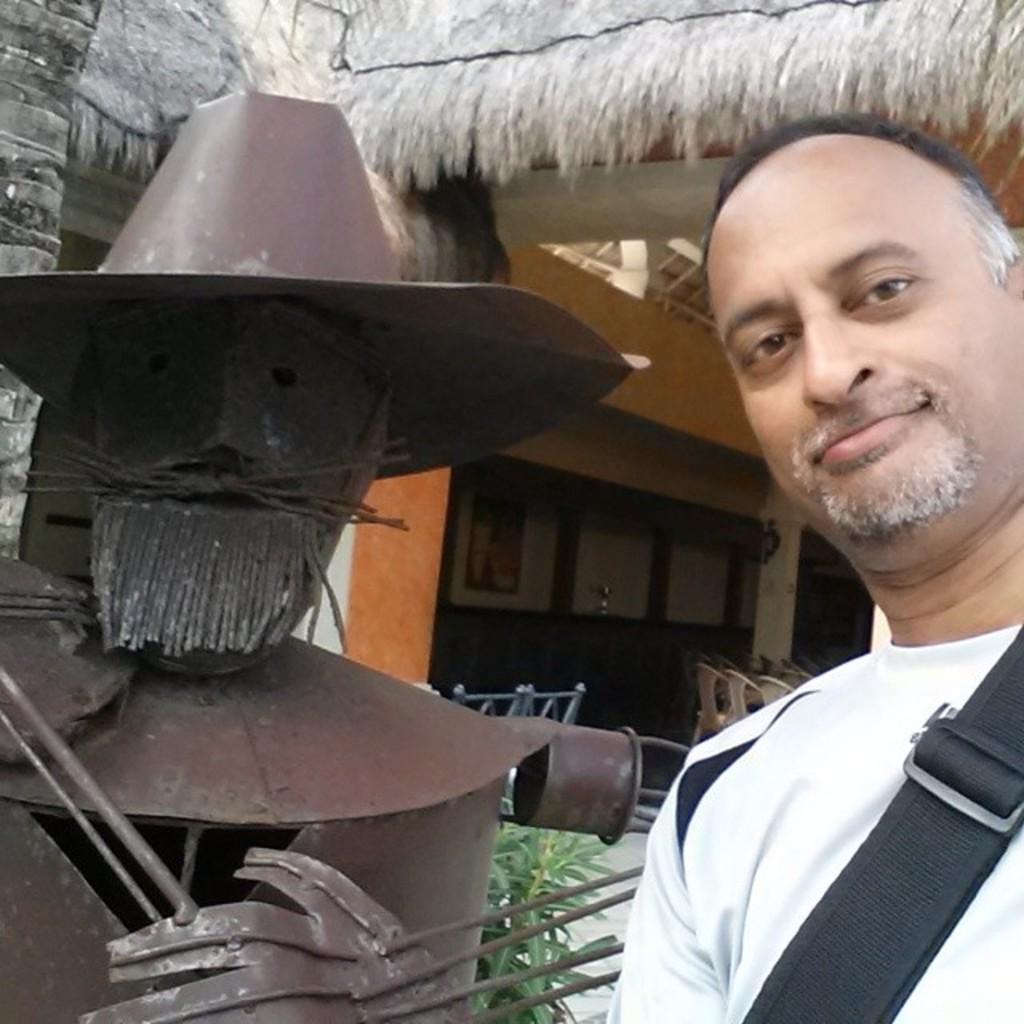How would you summarize this image in a sentence or two? In this picture we can see a person and in the background we can see a house,plants. 